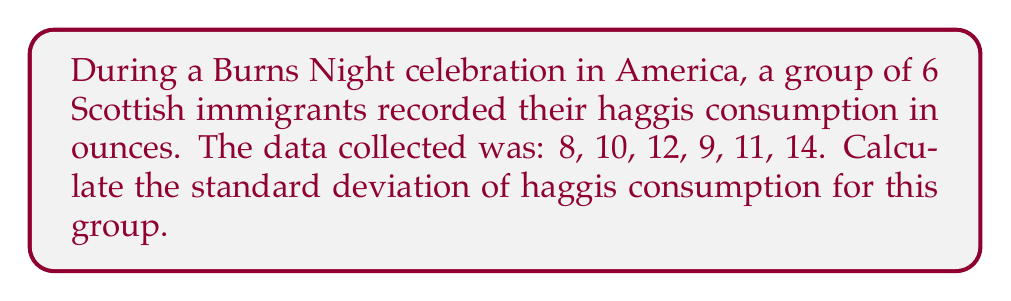Could you help me with this problem? To calculate the standard deviation, we'll follow these steps:

1. Calculate the mean ($\mu$) of the data:
   $$\mu = \frac{8 + 10 + 12 + 9 + 11 + 14}{6} = \frac{64}{6} = 10.67$$

2. Calculate the squared differences from the mean:
   $$(8 - 10.67)^2 = (-2.67)^2 = 7.13$$
   $$(10 - 10.67)^2 = (-0.67)^2 = 0.45$$
   $$(12 - 10.67)^2 = (1.33)^2 = 1.77$$
   $$(9 - 10.67)^2 = (-1.67)^2 = 2.79$$
   $$(11 - 10.67)^2 = (0.33)^2 = 0.11$$
   $$(14 - 10.67)^2 = (3.33)^2 = 11.09$$

3. Calculate the variance ($\sigma^2$) by finding the average of these squared differences:
   $$\sigma^2 = \frac{7.13 + 0.45 + 1.77 + 2.79 + 0.11 + 11.09}{6} = \frac{23.34}{6} = 3.89$$

4. Calculate the standard deviation ($\sigma$) by taking the square root of the variance:
   $$\sigma = \sqrt{3.89} = 1.97$$

Therefore, the standard deviation of haggis consumption for this group is approximately 1.97 ounces.
Answer: $1.97$ ounces (rounded to two decimal places) 